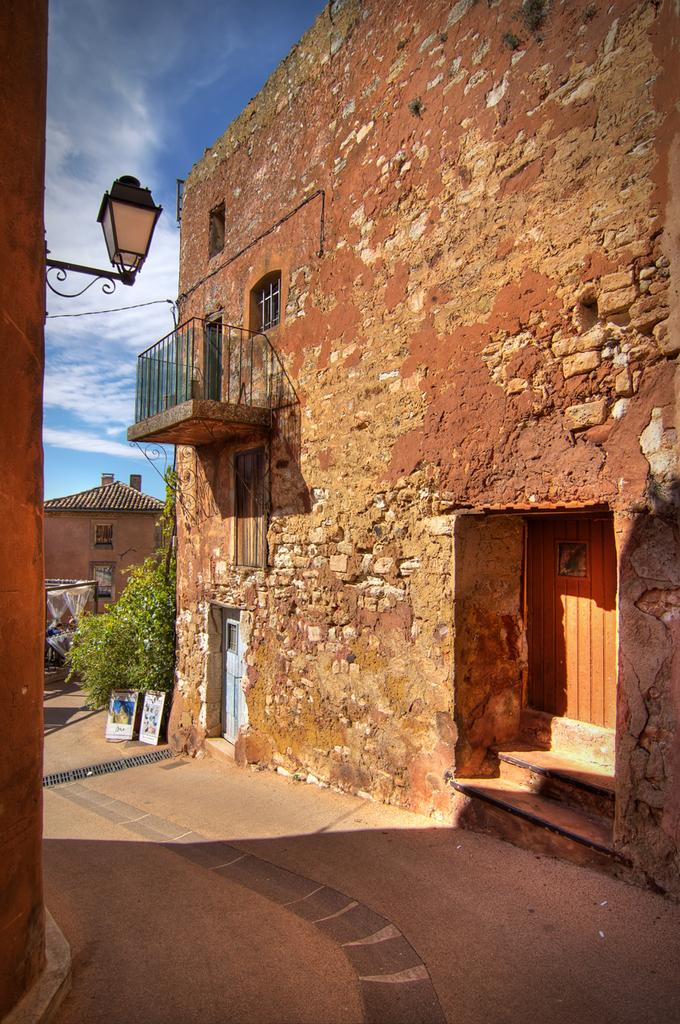What can be seen running through the area between the buildings in the image? There is a path in the image that runs between the buildings. What are the staircases used for in the image? The staircases are used for navigating between different levels in the image. What are the lights attached to in the image? The lights are attached to the walls in the image. Can you see a crown on anyone's head in the image? There is no crown visible in the image. What type of body is present in the image? There is no body present in the image; it is an architectural scene with a path, staircases, and lights. 